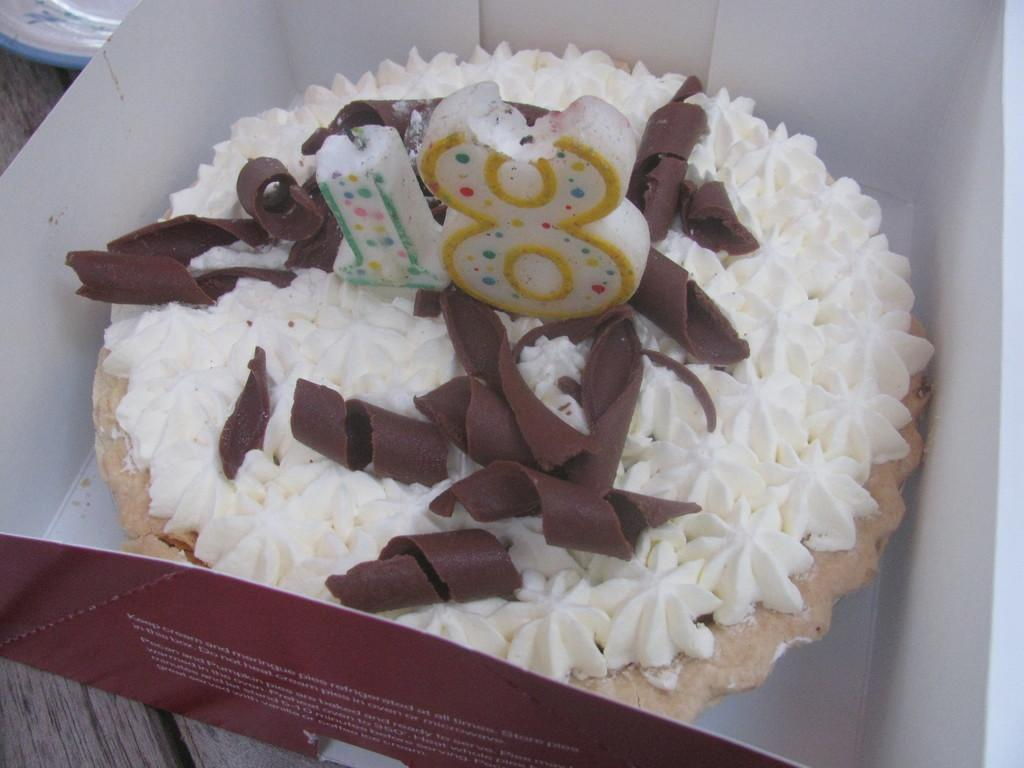What is the main piece of furniture in the image? There is a table in the image. What is placed on the table? There is a box on the table. What is inside the box? There is a cake and a candle in the box. Can you describe the location of another object on the table? There is a plate in the left corner of the table. How many planes are flying over the cake in the image? There are no planes visible in the image; it only shows a table with a box containing a cake and a candle. 